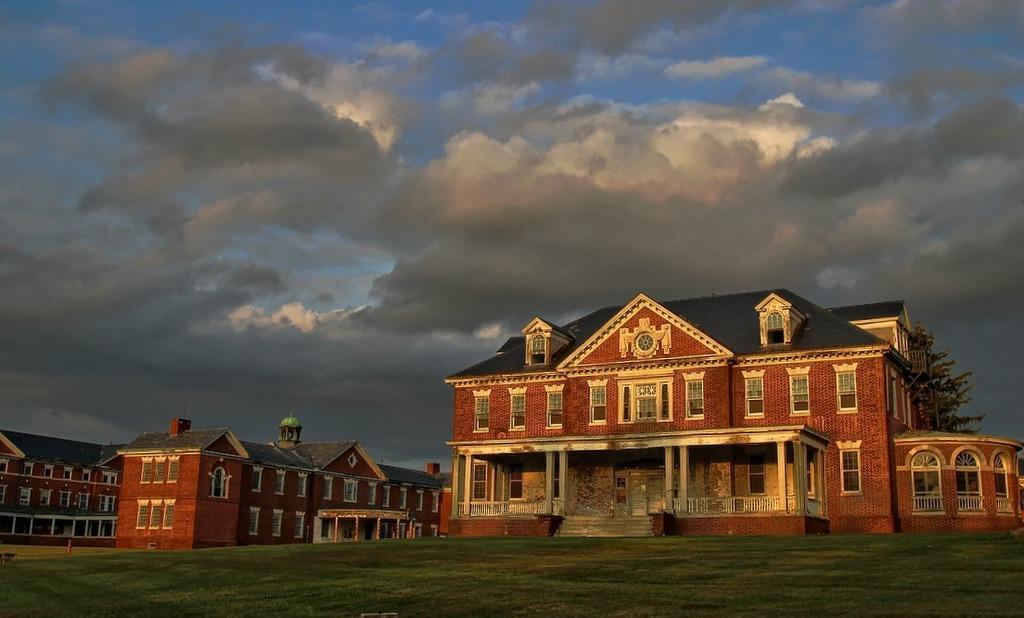In one or two sentences, can you explain what this image depicts? In this image I can see the ground, some grass on the ground and few buildings which are brown, cream and black in color. In the background I can see few trees and the sky. 